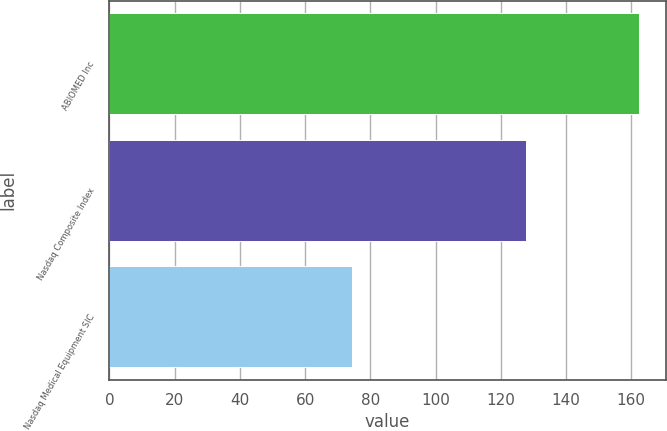Convert chart. <chart><loc_0><loc_0><loc_500><loc_500><bar_chart><fcel>ABIOMED Inc<fcel>Nasdaq Composite Index<fcel>Nasdaq Medical Equipment SIC<nl><fcel>162.45<fcel>127.66<fcel>74.4<nl></chart> 